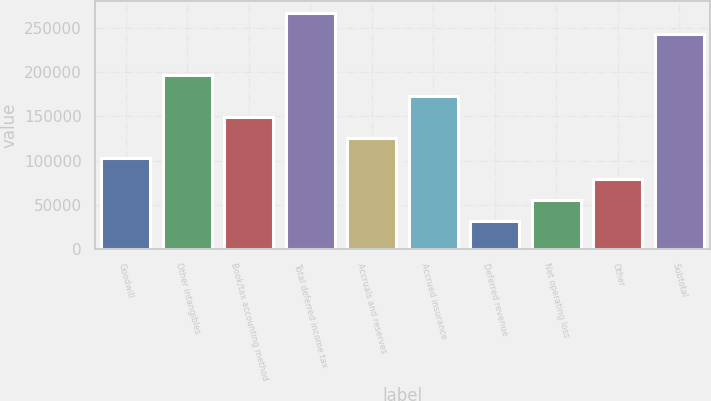<chart> <loc_0><loc_0><loc_500><loc_500><bar_chart><fcel>Goodwill<fcel>Other intangibles<fcel>Book/tax accounting method<fcel>Total deferred income tax<fcel>Accruals and reserves<fcel>Accrued insurance<fcel>Deferred revenue<fcel>Net operating loss<fcel>Other<fcel>Subtotal<nl><fcel>102515<fcel>196468<fcel>149492<fcel>266933<fcel>126004<fcel>172980<fcel>32050.3<fcel>55538.6<fcel>79026.9<fcel>243445<nl></chart> 